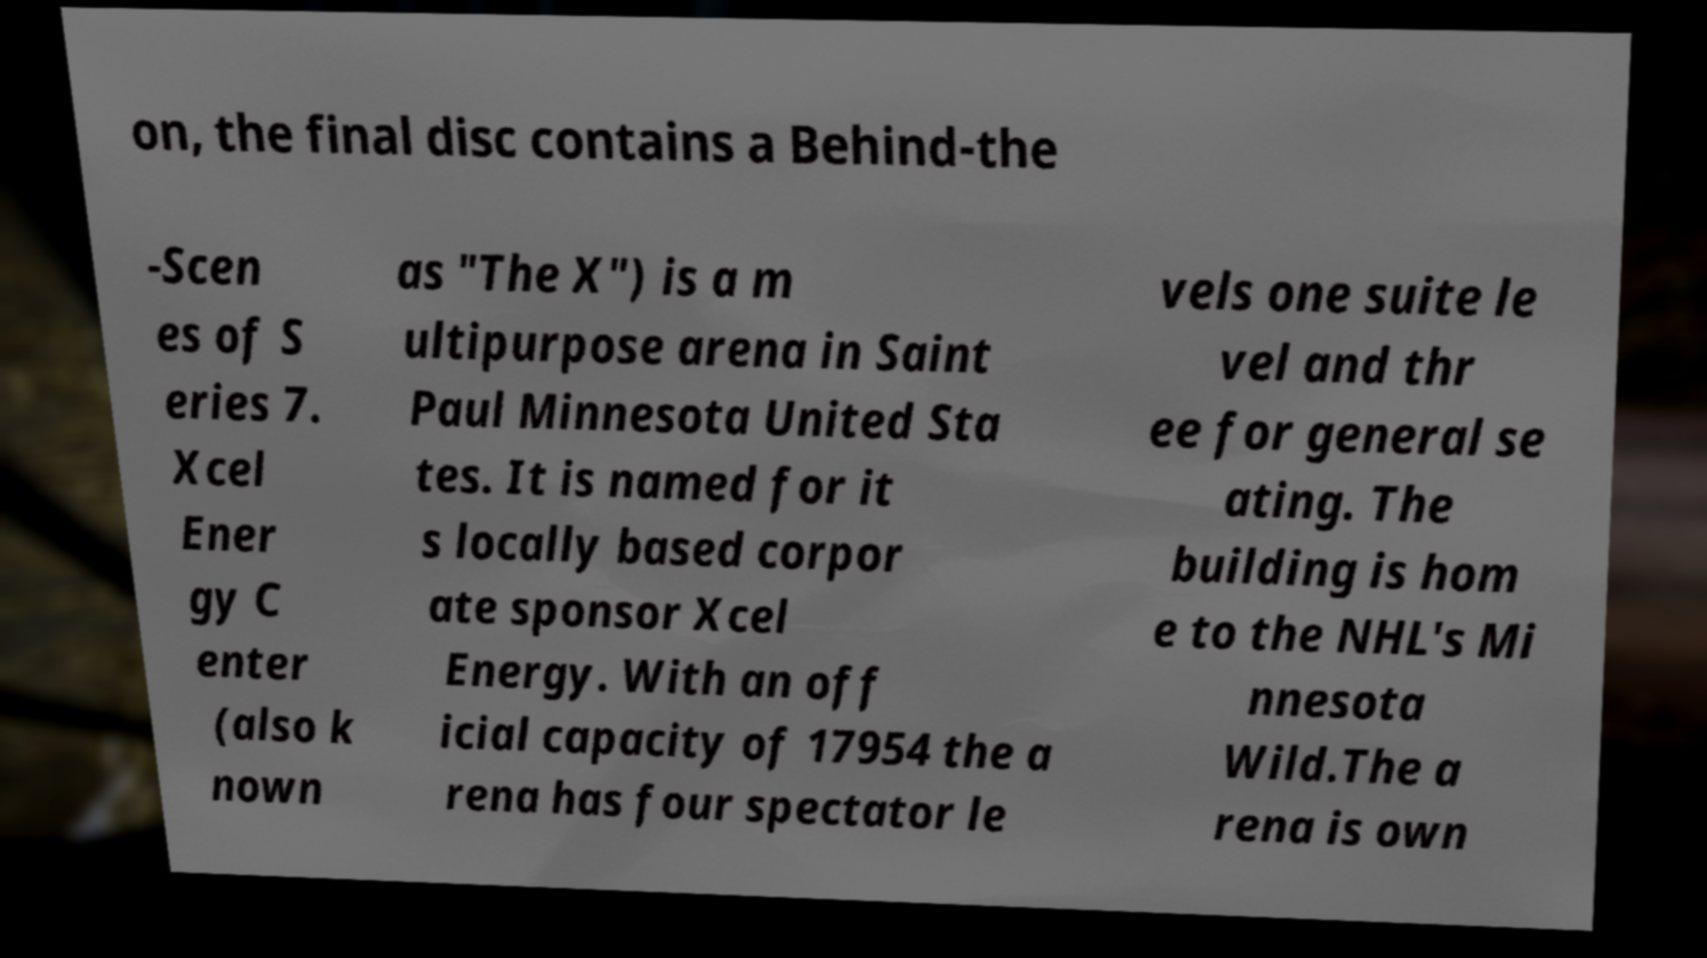Could you assist in decoding the text presented in this image and type it out clearly? on, the final disc contains a Behind-the -Scen es of S eries 7. Xcel Ener gy C enter (also k nown as "The X") is a m ultipurpose arena in Saint Paul Minnesota United Sta tes. It is named for it s locally based corpor ate sponsor Xcel Energy. With an off icial capacity of 17954 the a rena has four spectator le vels one suite le vel and thr ee for general se ating. The building is hom e to the NHL's Mi nnesota Wild.The a rena is own 